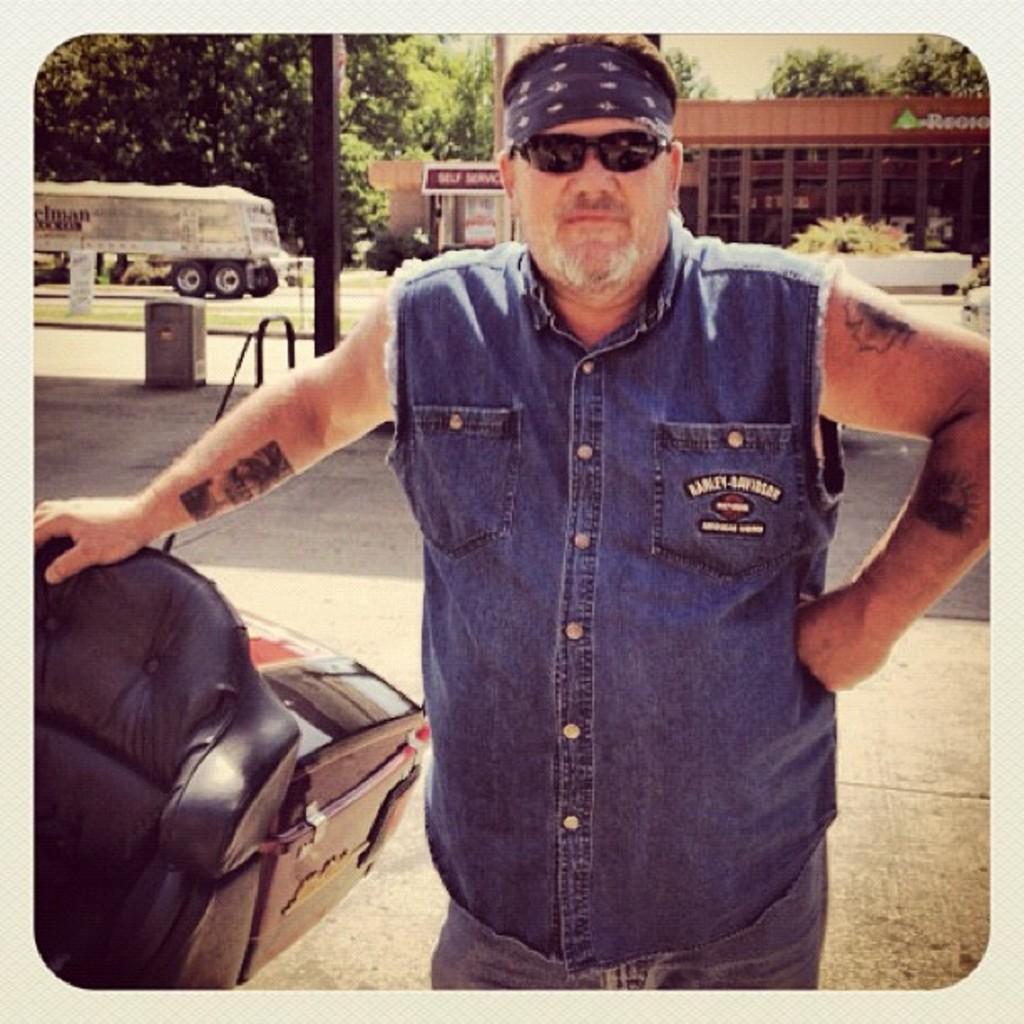How would you summarize this image in a sentence or two? In this image I can see a person standing, wearing goggles and headband. There are poles, trees and buildings at the back. There is sky at the top. 